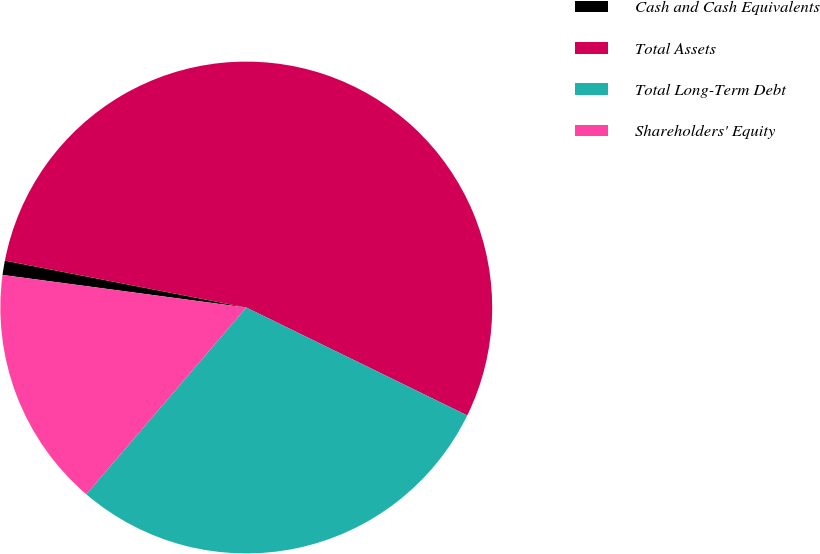Convert chart to OTSL. <chart><loc_0><loc_0><loc_500><loc_500><pie_chart><fcel>Cash and Cash Equivalents<fcel>Total Assets<fcel>Total Long-Term Debt<fcel>Shareholders' Equity<nl><fcel>0.94%<fcel>54.17%<fcel>29.04%<fcel>15.84%<nl></chart> 